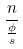<formula> <loc_0><loc_0><loc_500><loc_500>\frac { n } { \frac { \phi } { s } }</formula> 